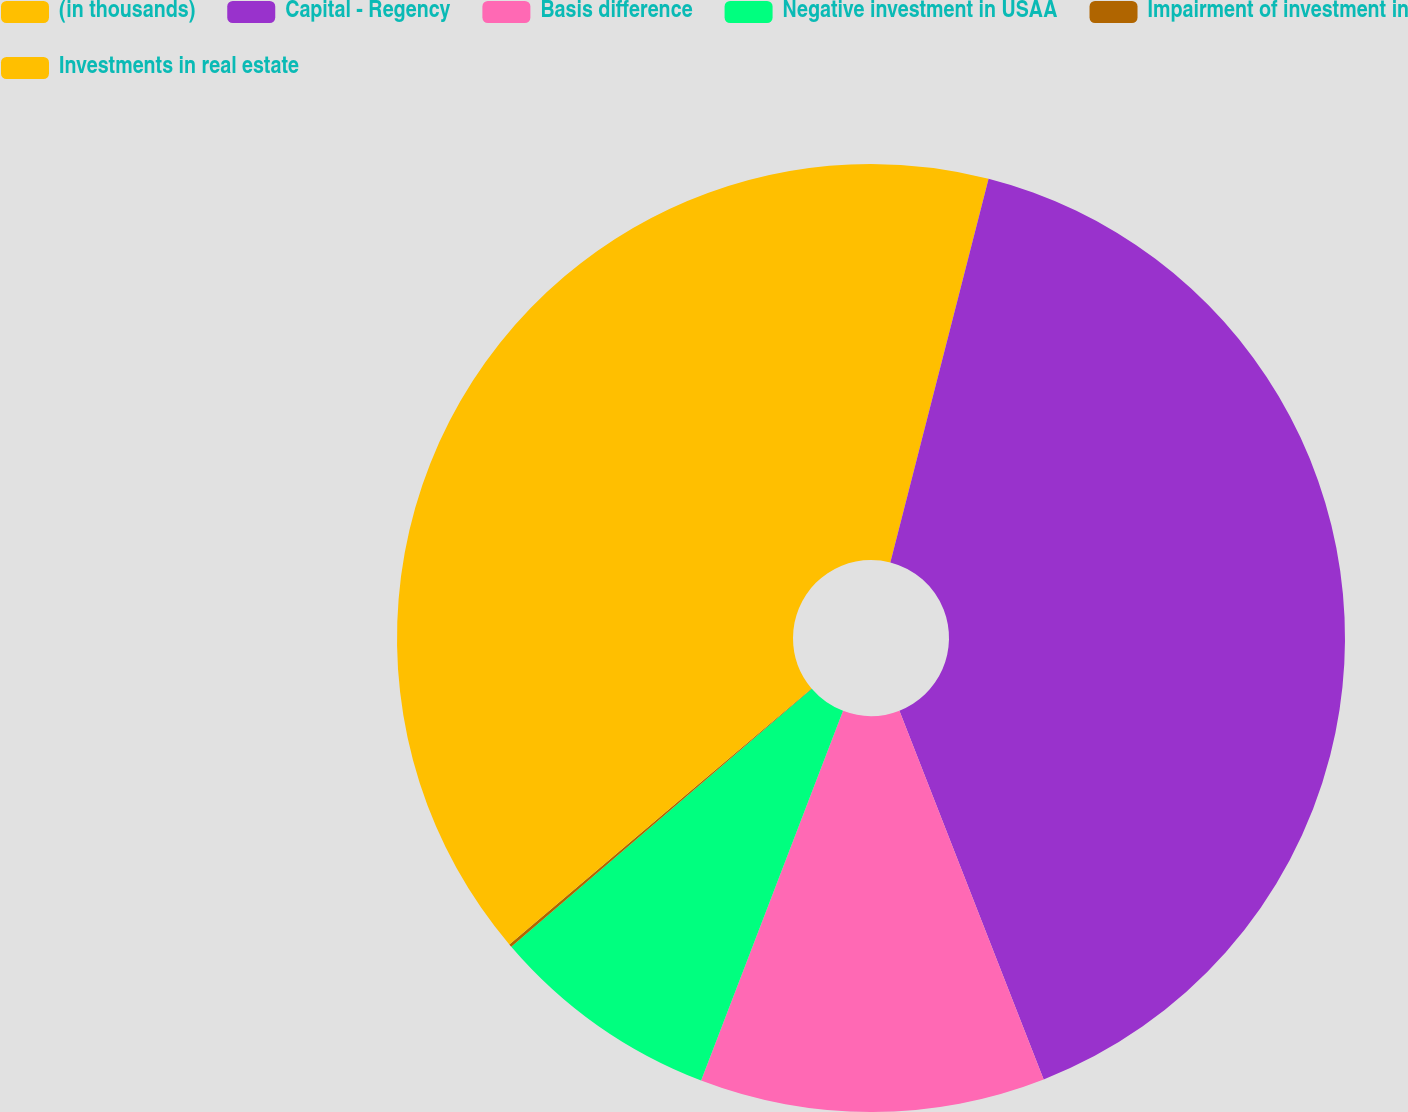<chart> <loc_0><loc_0><loc_500><loc_500><pie_chart><fcel>(in thousands)<fcel>Capital - Regency<fcel>Basis difference<fcel>Negative investment in USAA<fcel>Impairment of investment in<fcel>Investments in real estate<nl><fcel>3.99%<fcel>40.08%<fcel>11.77%<fcel>7.88%<fcel>0.1%<fcel>36.19%<nl></chart> 